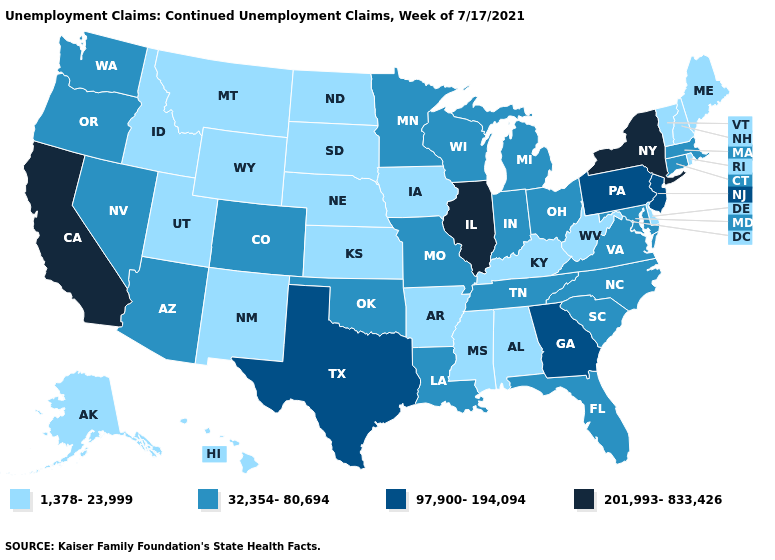What is the value of Massachusetts?
Quick response, please. 32,354-80,694. Does Utah have the highest value in the USA?
Answer briefly. No. Name the states that have a value in the range 97,900-194,094?
Quick response, please. Georgia, New Jersey, Pennsylvania, Texas. Which states have the lowest value in the West?
Concise answer only. Alaska, Hawaii, Idaho, Montana, New Mexico, Utah, Wyoming. What is the value of Michigan?
Quick response, please. 32,354-80,694. Name the states that have a value in the range 201,993-833,426?
Answer briefly. California, Illinois, New York. What is the value of Arizona?
Short answer required. 32,354-80,694. Name the states that have a value in the range 97,900-194,094?
Give a very brief answer. Georgia, New Jersey, Pennsylvania, Texas. Which states have the lowest value in the USA?
Give a very brief answer. Alabama, Alaska, Arkansas, Delaware, Hawaii, Idaho, Iowa, Kansas, Kentucky, Maine, Mississippi, Montana, Nebraska, New Hampshire, New Mexico, North Dakota, Rhode Island, South Dakota, Utah, Vermont, West Virginia, Wyoming. Does New York have the highest value in the Northeast?
Write a very short answer. Yes. Among the states that border Texas , does Louisiana have the highest value?
Write a very short answer. Yes. Does Texas have the same value as New Jersey?
Be succinct. Yes. Which states have the lowest value in the West?
Be succinct. Alaska, Hawaii, Idaho, Montana, New Mexico, Utah, Wyoming. Which states have the lowest value in the USA?
Keep it brief. Alabama, Alaska, Arkansas, Delaware, Hawaii, Idaho, Iowa, Kansas, Kentucky, Maine, Mississippi, Montana, Nebraska, New Hampshire, New Mexico, North Dakota, Rhode Island, South Dakota, Utah, Vermont, West Virginia, Wyoming. What is the value of Montana?
Give a very brief answer. 1,378-23,999. 